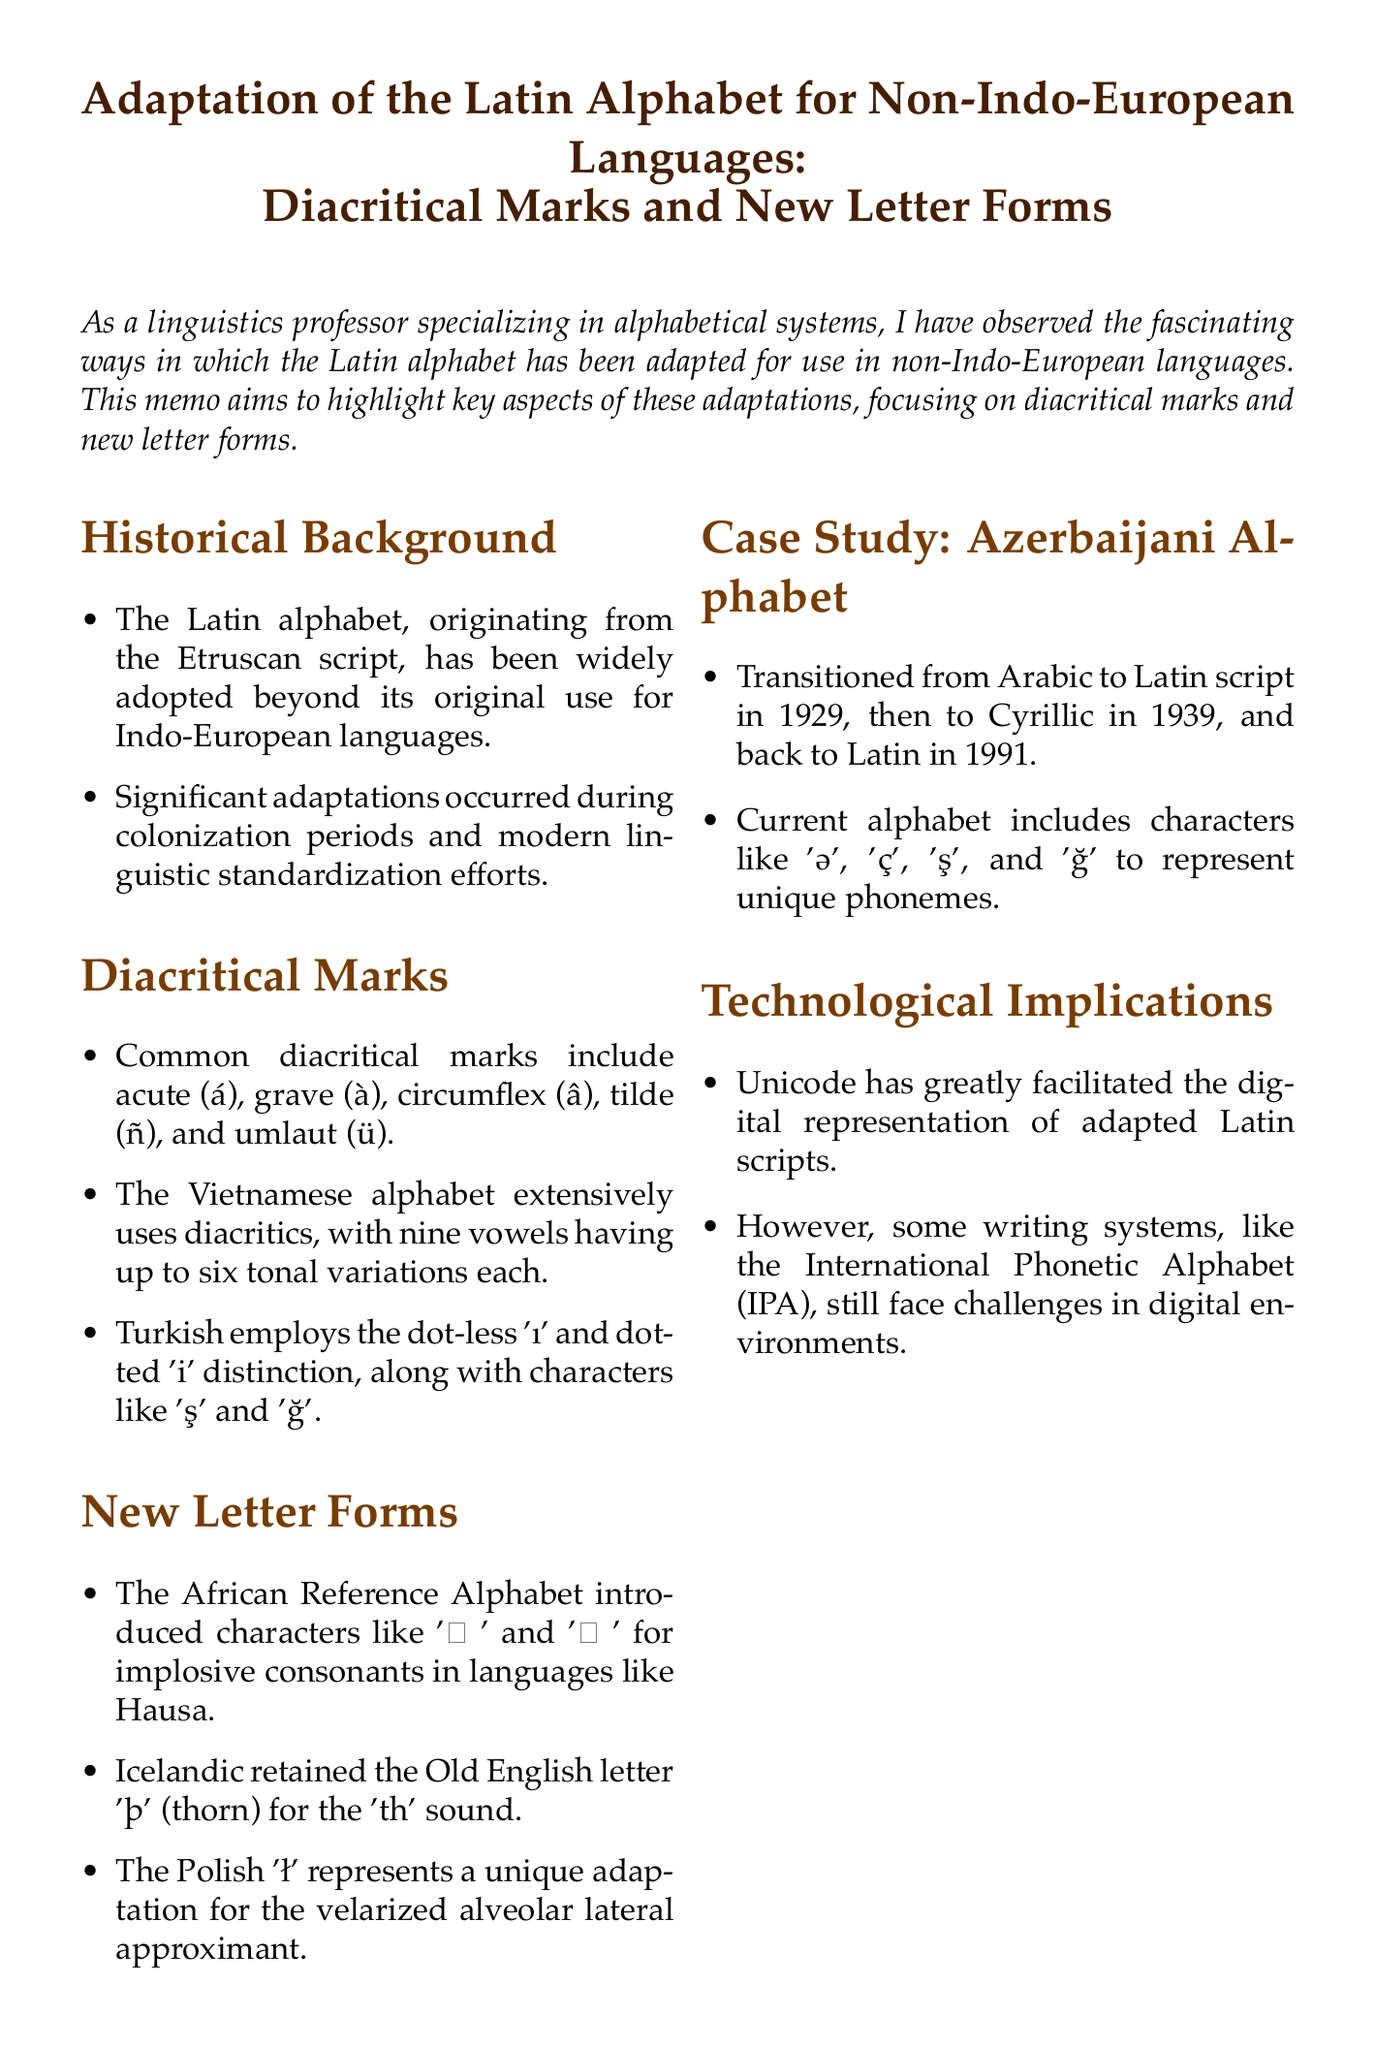What is the memo title? The title of the memo is stated at the beginning of the document, introducing the topic of adaptation of the Latin alphabet.
Answer: Adaptation of the Latin Alphabet for Non-Indo-European Languages: Diacritical Marks and New Letter Forms Which alphabet employs diacritical marks extensively with tonal variations? The document mentions that the Vietnamese alphabet has many vowels, indicating a significant use of diacritics for tonal variations.
Answer: Vietnamese What is the unique letter form introduced by the African Reference Alphabet? The document specifies that characters like 'ɓ' and 'ɗ' were introduced for specific consonant sounds in African languages.
Answer: ɓ and ɗ In which year did the Azerbaijani language transition back to the Latin script? The document provides a specific date for when the Azerbaijani alphabet returned to Latin script after previous changes.
Answer: 1991 What diacritical mark is commonly used in Turkish? The document notes specific characters employed in the Turkish script, highlighting a few distinct ones.
Answer: ş and ğ What is the primary technology facilitating digital representation of adapted Latin scripts? The document refers to a specific technology that has supported the digital formatting of these writing systems.
Answer: Unicode Which case study is mentioned in the document related to alphabet adaptation? The document includes a detailed analysis of one specific language's alphabet changes and usage.
Answer: Azerbaijani Alphabet What is the main conclusion of the memo? The conclusion section summarizes the overall findings and implications of the adaptations discussed in the memo.
Answer: Linguistic ingenuity and cultural exchange 